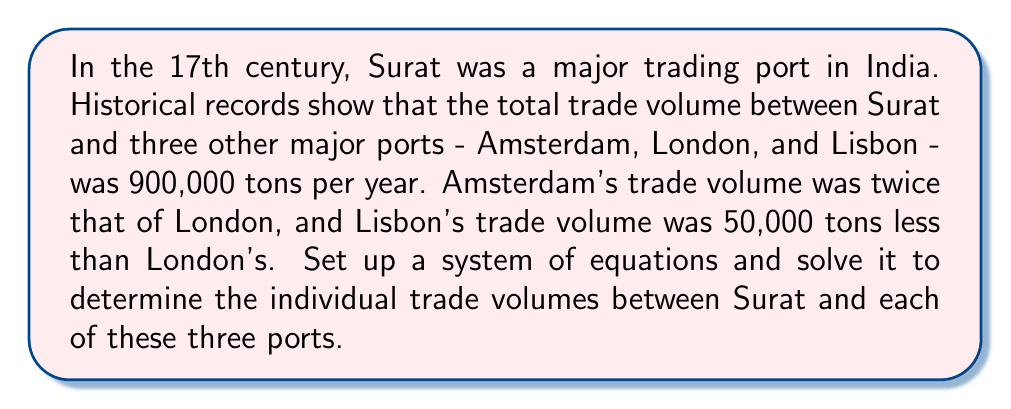Teach me how to tackle this problem. Let's approach this problem step by step:

1) First, let's define our variables:
   Let $x$ = London's trade volume with Surat
   Let $y$ = Amsterdam's trade volume with Surat
   Let $z$ = Lisbon's trade volume with Surat

2) Now, we can set up our system of equations based on the given information:

   Equation 1: Total trade volume
   $$x + y + z = 900,000$$

   Equation 2: Amsterdam's volume is twice London's
   $$y = 2x$$

   Equation 3: Lisbon's volume is 50,000 less than London's
   $$z = x - 50,000$$

3) Let's substitute equations 2 and 3 into equation 1:
   $$x + 2x + (x - 50,000) = 900,000$$

4) Simplify:
   $$4x - 50,000 = 900,000$$

5) Add 50,000 to both sides:
   $$4x = 950,000$$

6) Divide both sides by 4:
   $$x = 237,500$$

7) Now that we know $x$ (London's volume), we can find $y$ and $z$:
   $y = 2x = 2(237,500) = 475,000$
   $z = x - 50,000 = 237,500 - 50,000 = 187,500$

8) Let's verify our solution:
   $x + y + z = 237,500 + 475,000 + 187,500 = 900,000$
   This confirms our solution is correct.
Answer: The trade volumes between Surat and the three ports were:
Amsterdam: 475,000 tons
London: 237,500 tons
Lisbon: 187,500 tons 